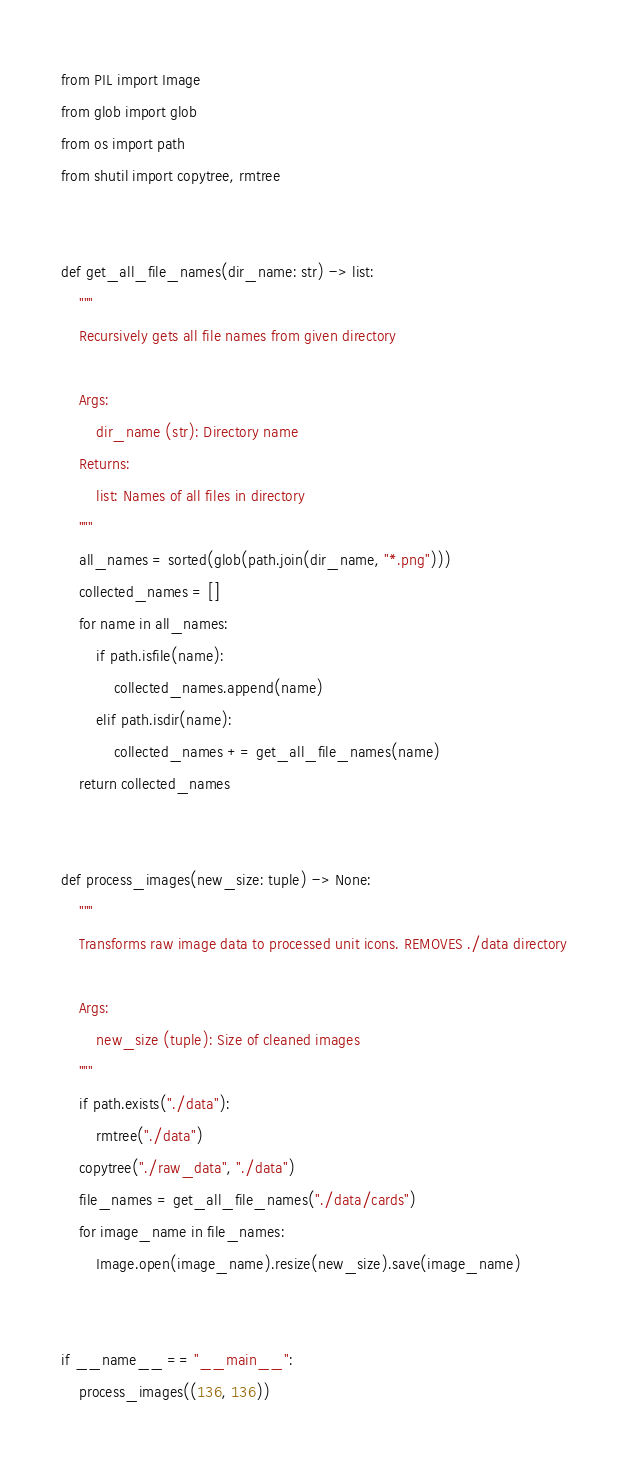Convert code to text. <code><loc_0><loc_0><loc_500><loc_500><_Python_>from PIL import Image
from glob import glob
from os import path
from shutil import copytree, rmtree


def get_all_file_names(dir_name: str) -> list:
    """
    Recursively gets all file names from given directory

    Args:
        dir_name (str): Directory name
    Returns:
        list: Names of all files in directory
    """
    all_names = sorted(glob(path.join(dir_name, "*.png")))
    collected_names = []
    for name in all_names:
        if path.isfile(name):
            collected_names.append(name)
        elif path.isdir(name):
            collected_names += get_all_file_names(name)
    return collected_names


def process_images(new_size: tuple) -> None:
    """
    Transforms raw image data to processed unit icons. REMOVES ./data directory

    Args:
        new_size (tuple): Size of cleaned images
    """
    if path.exists("./data"):
        rmtree("./data")
    copytree("./raw_data", "./data")
    file_names = get_all_file_names("./data/cards")
    for image_name in file_names:
        Image.open(image_name).resize(new_size).save(image_name)


if __name__ == "__main__":
    process_images((136, 136))
</code> 